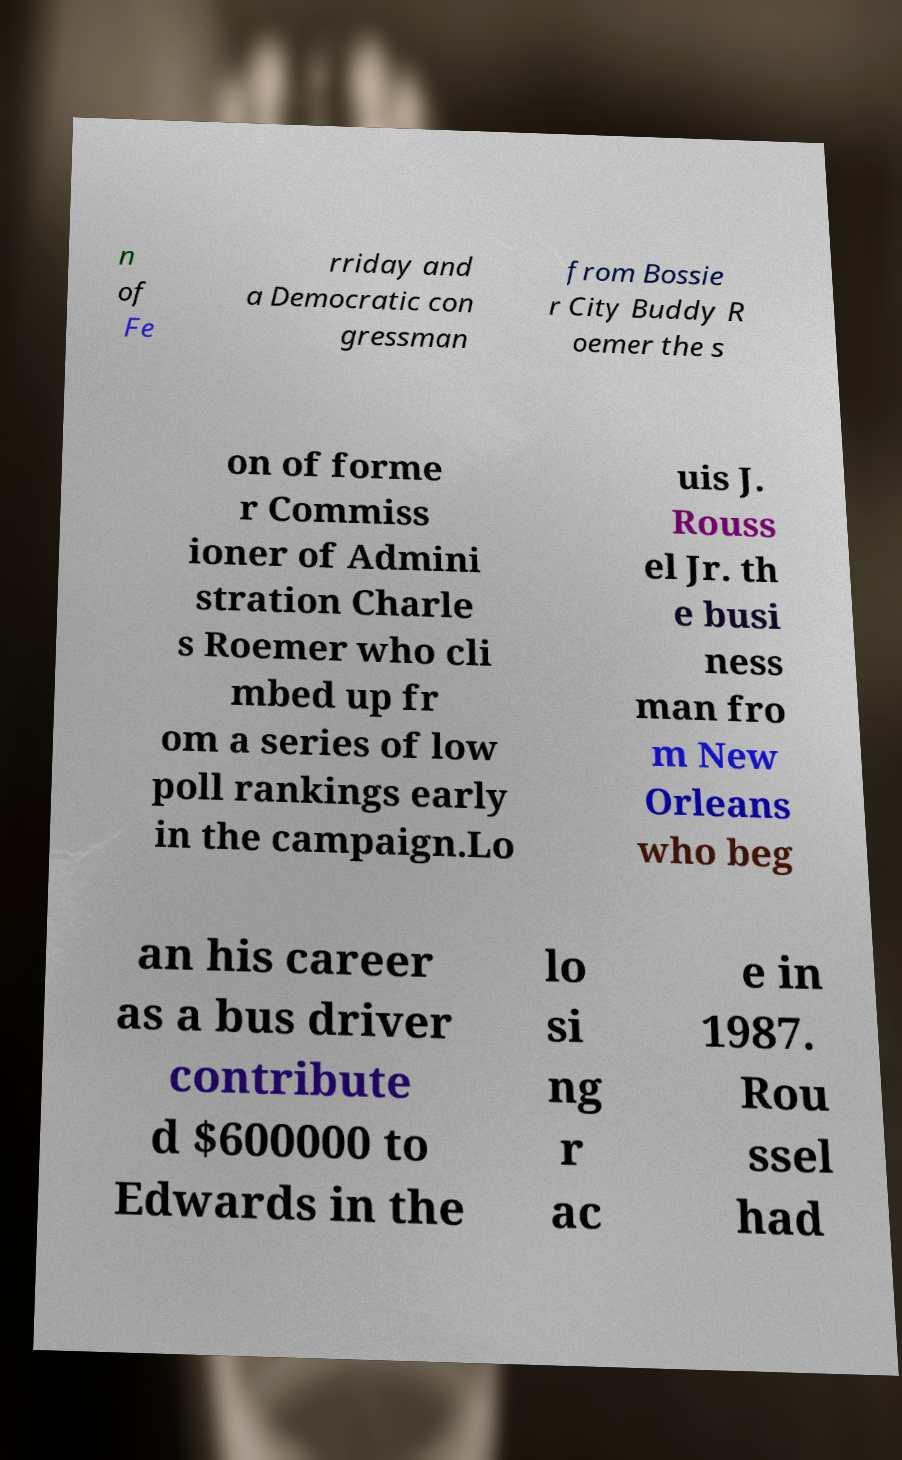Could you assist in decoding the text presented in this image and type it out clearly? n of Fe rriday and a Democratic con gressman from Bossie r City Buddy R oemer the s on of forme r Commiss ioner of Admini stration Charle s Roemer who cli mbed up fr om a series of low poll rankings early in the campaign.Lo uis J. Rouss el Jr. th e busi ness man fro m New Orleans who beg an his career as a bus driver contribute d $600000 to Edwards in the lo si ng r ac e in 1987. Rou ssel had 